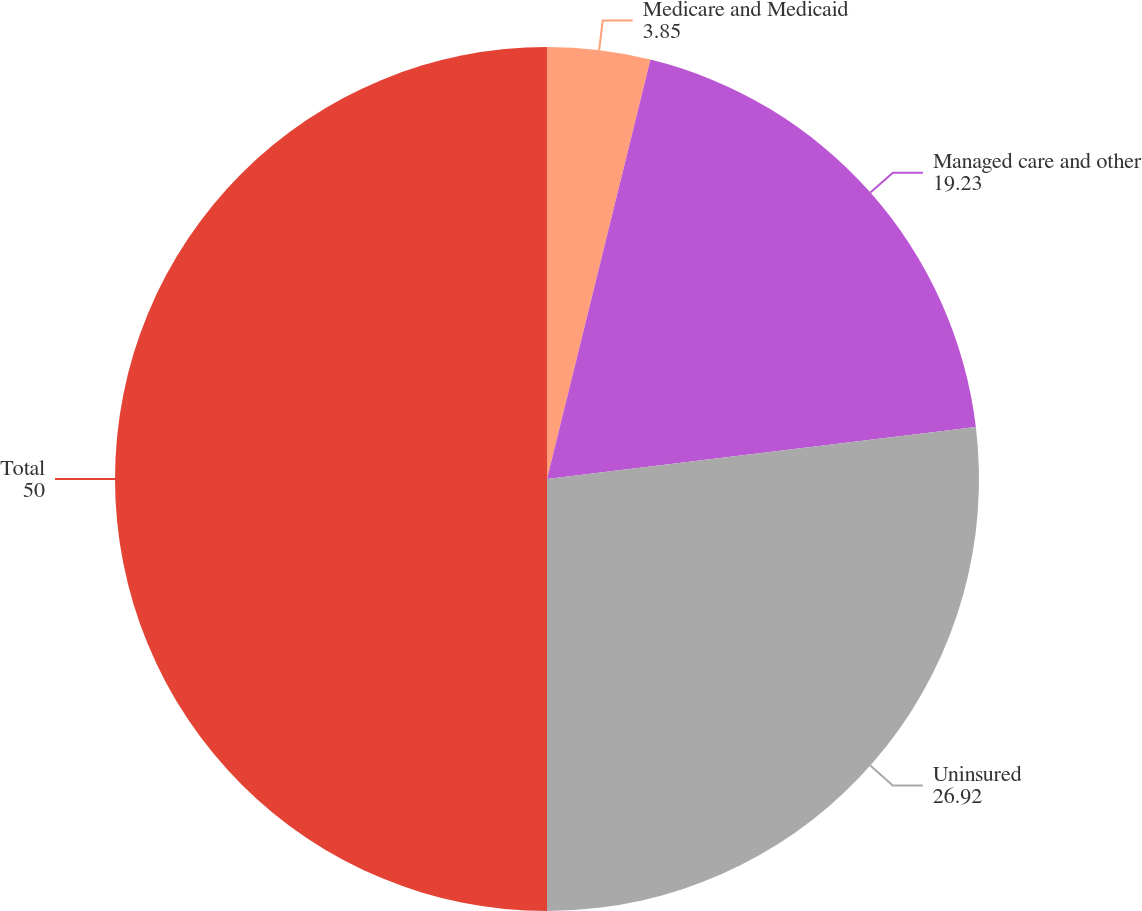Convert chart to OTSL. <chart><loc_0><loc_0><loc_500><loc_500><pie_chart><fcel>Medicare and Medicaid<fcel>Managed care and other<fcel>Uninsured<fcel>Total<nl><fcel>3.85%<fcel>19.23%<fcel>26.92%<fcel>50.0%<nl></chart> 